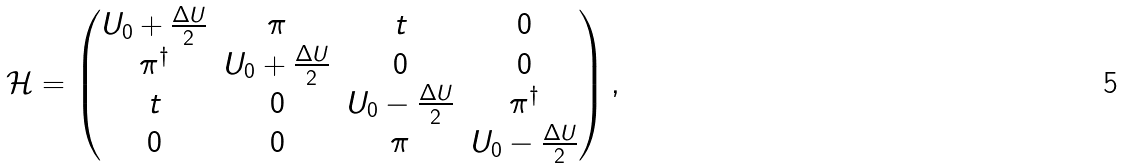<formula> <loc_0><loc_0><loc_500><loc_500>\mathcal { H } = \begin{pmatrix} U _ { 0 } + \frac { \Delta U } { 2 } & \pi & t & 0 \\ \pi ^ { \dagger } & U _ { 0 } + \frac { \Delta U } { 2 } & 0 & 0 \\ t & 0 & U _ { 0 } - \frac { \Delta U } { 2 } & \pi ^ { \dagger } \\ 0 & 0 & \pi & U _ { 0 } - \frac { \Delta U } { 2 } \end{pmatrix} ,</formula> 